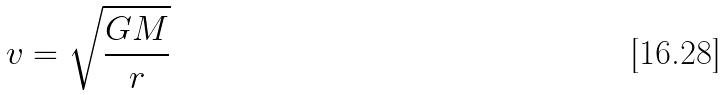<formula> <loc_0><loc_0><loc_500><loc_500>v = \sqrt { \frac { G M } { r } }</formula> 